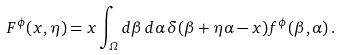Convert formula to latex. <formula><loc_0><loc_0><loc_500><loc_500>F ^ { \phi } ( x , \eta ) = x \int _ { \mathit \Omega } d \beta \, d \alpha \, \delta ( \beta + \eta \alpha - x ) f ^ { \phi } ( \beta , \alpha ) \, .</formula> 